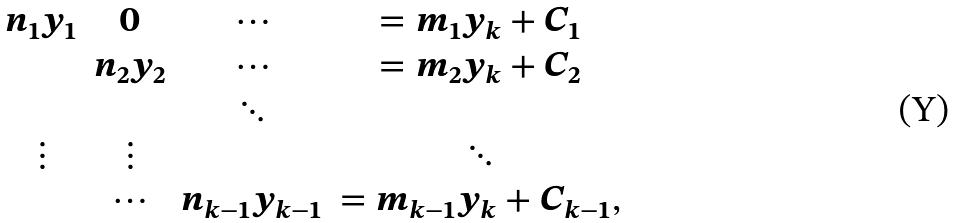<formula> <loc_0><loc_0><loc_500><loc_500>\begin{array} { c c c c } n _ { 1 } y _ { 1 } & 0 & \cdots & = m _ { 1 } y _ { k } + C _ { 1 } \\ & n _ { 2 } y _ { 2 } & \cdots & = m _ { 2 } y _ { k } + C _ { 2 } \\ & & \ddots & \\ \vdots & \vdots & & \ddots \\ & \cdots & n _ { k - 1 } y _ { k - 1 } & = m _ { k - 1 } y _ { k } + C _ { k - 1 } , \\ \end{array}</formula> 